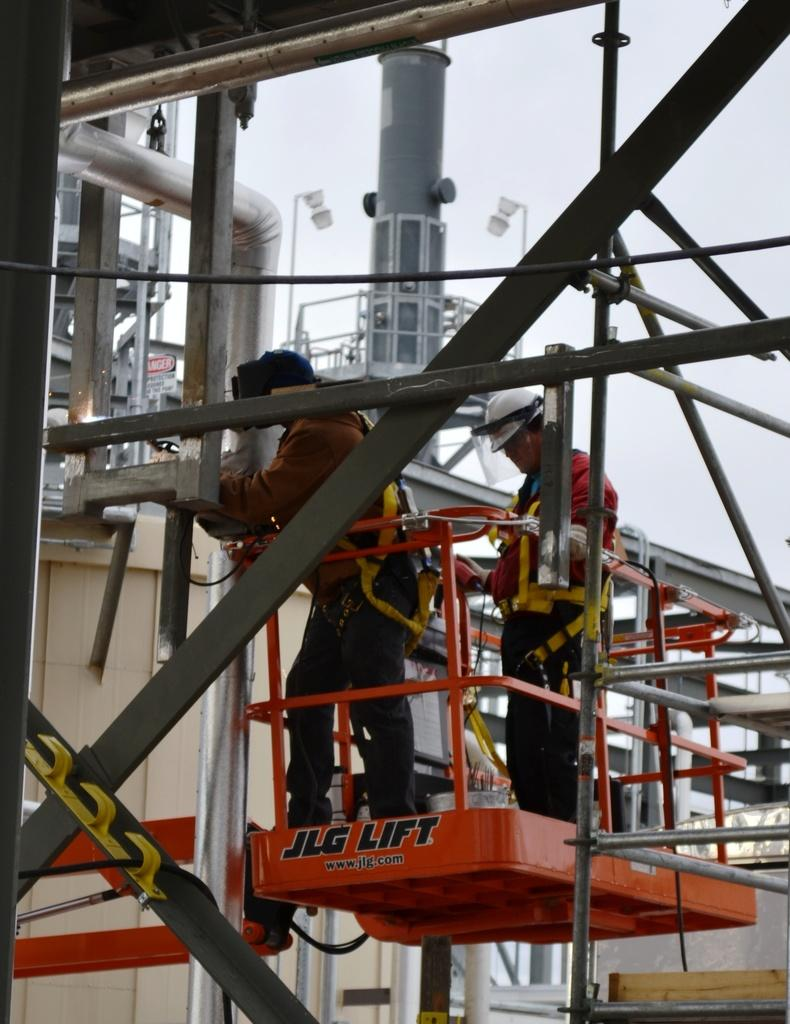What are the two persons doing in the image? The two persons are standing on a construction lift. What can be seen in the background of the image? There is a pipeline and lights in the background of the image. What is visible in the sky in the image? The sky is visible in the background of the image. What is present in the foreground of the image? There are iron bars in the foreground of the image. What type of silver material is being used to build the pipeline in the image? There is no mention of silver material in the image; the pipeline is not described as being made of silver. 